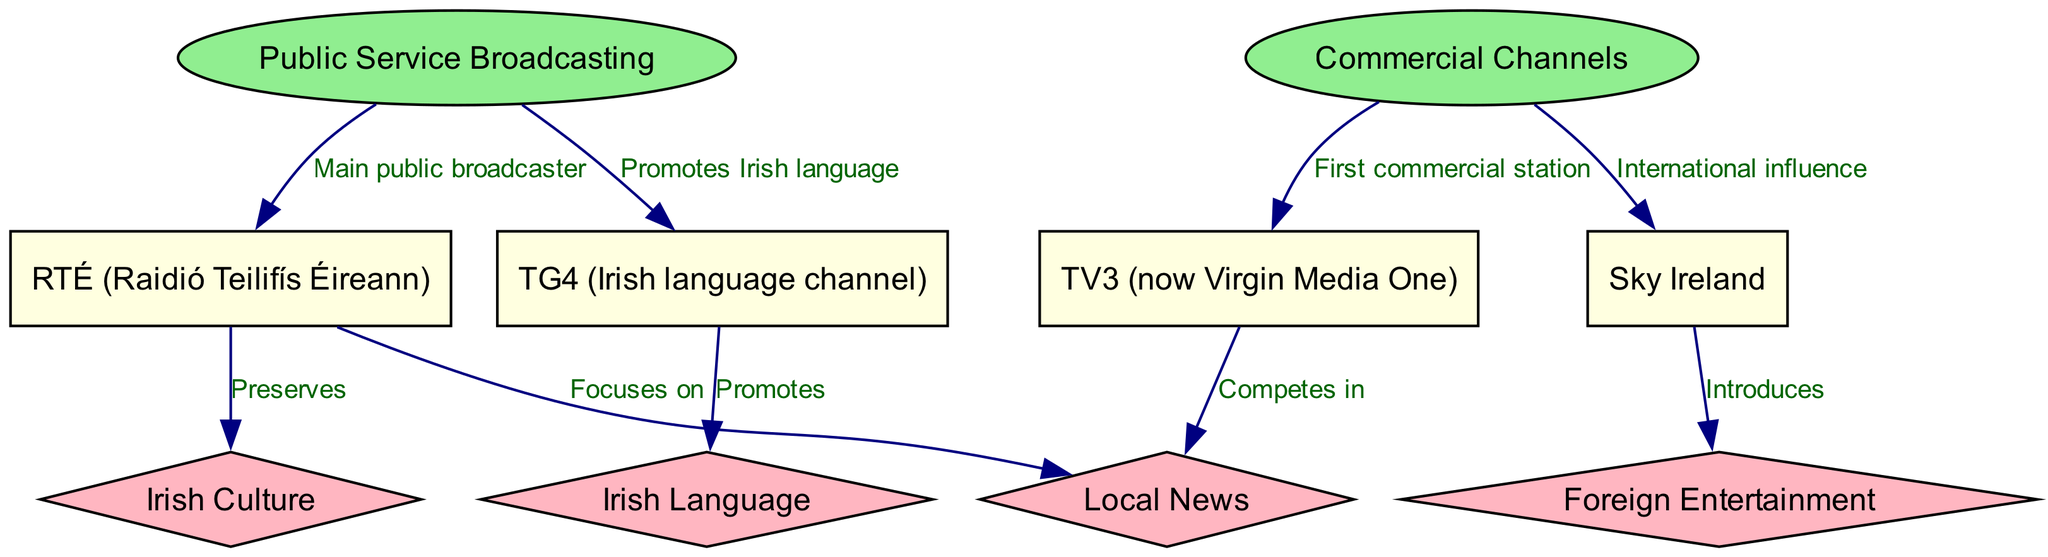What is the main public broadcaster in Ireland? The diagram indicates that the main public broadcaster is RTÉ, as it is directly connected to the Public Service Broadcasting node with a labeled edge stating "Main public broadcaster."
Answer: RTÉ Which commercial station is the first in Ireland? The edge labeled "First commercial station" leads from the Commercial Channels node to TV3, indicating that TV3 is the first commercial station in Ireland.
Answer: TV3 How many nodes represent channels in the diagram? The channels are represented by the nodes RTÉ, TG4, TV3, and SKY. Counting these nodes gives a total of four channel nodes.
Answer: 4 What does TG4 promote? The diagram shows an edge from TG4 to the Irish Language node with the label "Promotes," indicating that TG4 promotes the Irish language.
Answer: Irish language How does RTÉ contribute to Irish culture? The diagram connects RTÉ to Irish Culture, with an edge labeled "Preserves," suggesting that RTÉ plays a role in preserving Irish culture.
Answer: Preserves Which type of entertainment does SKY introduce? The connection from SKY to Foreign Entertainment shows that SKY introduces foreign entertainment, as indicated by the label on the edge.
Answer: Foreign Entertainment What is the relationship between TV3 and Local News? There is an edge labeled "Competes in" leading from TV3 to the Local News node, indicating that TV3 competes in local news broadcasting.
Answer: Competes in What node does Public Service Broadcasting link to regarding the Irish language? The Public Service Broadcasting node is linked to TG4 with an edge labeled "Promotes Irish language," indicating its connection to promoting the Irish language through TG4.
Answer: TG4 How many edges are in the diagram? Counting the connections (edges) in the diagram shows there are eight edges that connect various nodes, detailing the relationships.
Answer: 8 